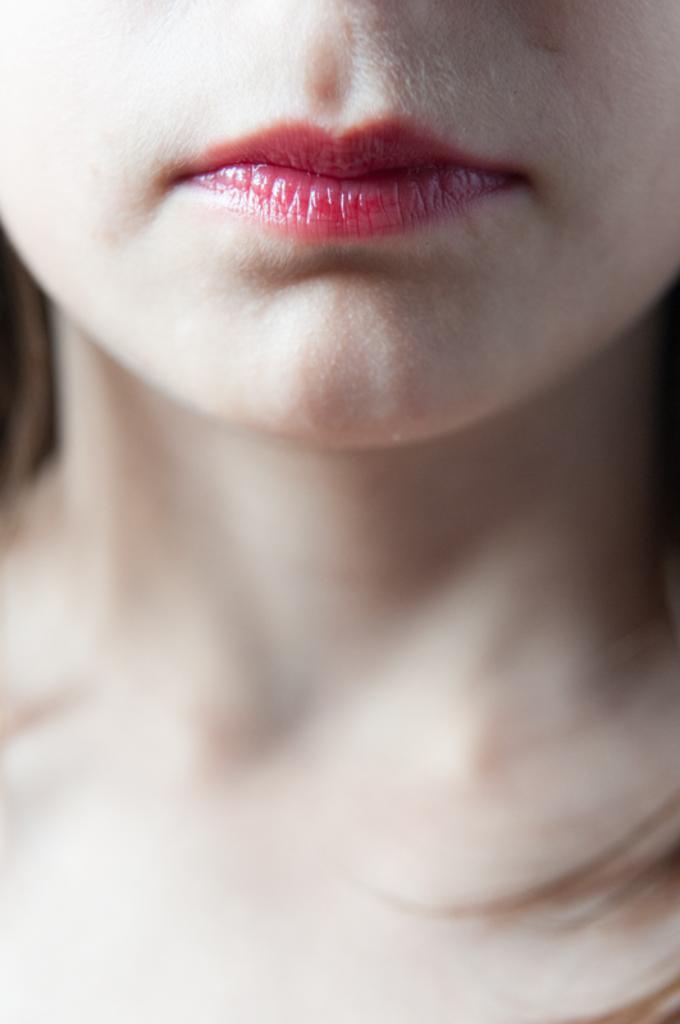Can you describe this image briefly? In this image, we can see woman lips and hair. 